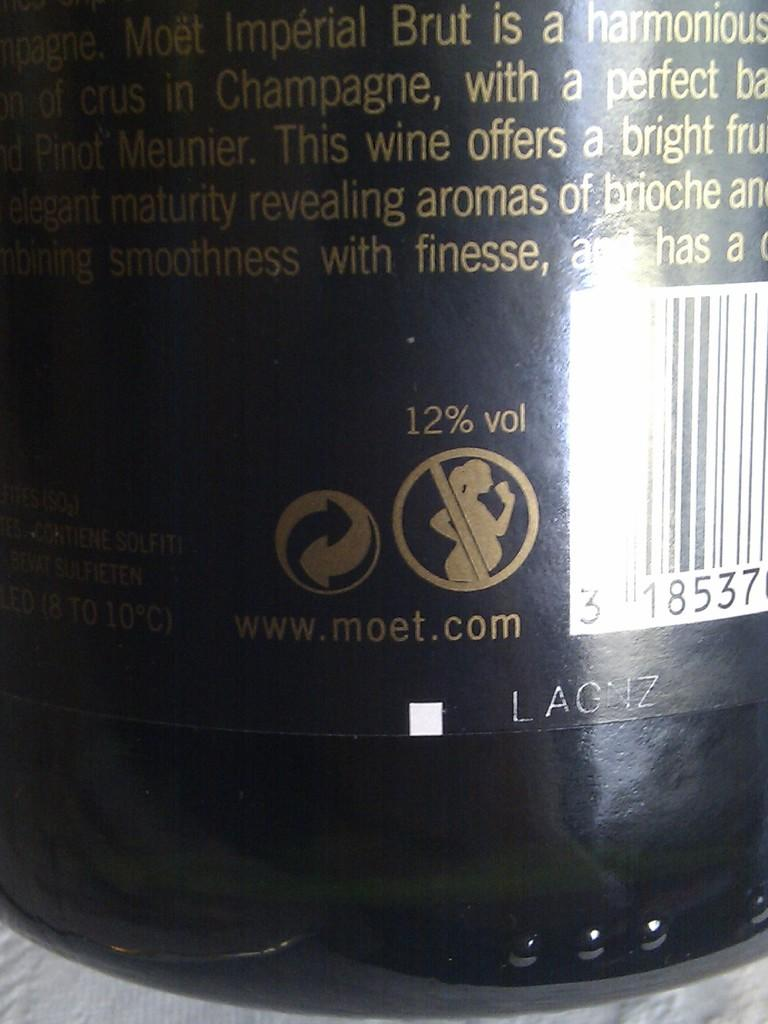What object is present in the image? There is a bottle in the image. What can be found on the surface of the bottle? The bottle has text and pictures on it. Is there any additional information on the bottle? Yes, the bottle has a bar code. Can you see any feathers on the bottle in the image? No, there are no feathers present on the bottle in the image. What answer does the bottle provide in the image? The bottle does not provide an answer in the image, as it is an inanimate object. 